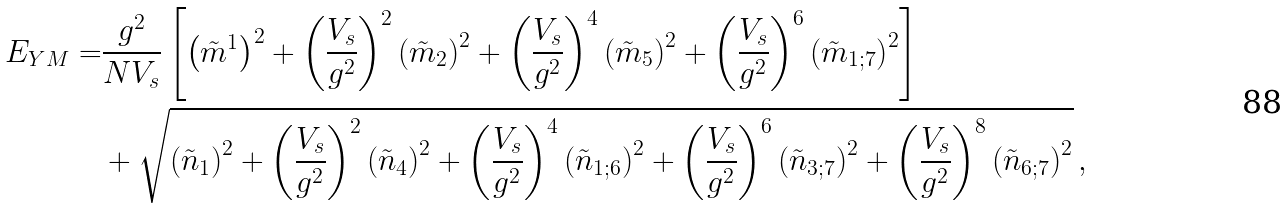<formula> <loc_0><loc_0><loc_500><loc_500>E _ { Y M } = & \frac { g ^ { 2 } } { N V _ { s } } \left [ \left ( \tilde { m } ^ { 1 } \right ) ^ { 2 } + \left ( \frac { V _ { s } } { g ^ { 2 } } \right ) ^ { 2 } \left ( \tilde { m } _ { 2 } \right ) ^ { 2 } + \left ( \frac { V _ { s } } { g ^ { 2 } } \right ) ^ { 4 } \left ( \tilde { m } _ { 5 } \right ) ^ { 2 } + \left ( \frac { V _ { s } } { g ^ { 2 } } \right ) ^ { 6 } \left ( \tilde { m } _ { 1 ; 7 } \right ) ^ { 2 } \right ] \\ & + \sqrt { \left ( \tilde { n } _ { 1 } \right ) ^ { 2 } + \left ( \frac { V _ { s } } { g ^ { 2 } } \right ) ^ { 2 } \left ( \tilde { n } _ { 4 } \right ) ^ { 2 } + \left ( \frac { V _ { s } } { g ^ { 2 } } \right ) ^ { 4 } \left ( \tilde { n } _ { 1 ; 6 } \right ) ^ { 2 } + \left ( \frac { V _ { s } } { g ^ { 2 } } \right ) ^ { 6 } \left ( \tilde { n } _ { 3 ; 7 } \right ) ^ { 2 } + \left ( \frac { V _ { s } } { g ^ { 2 } } \right ) ^ { 8 } \left ( \tilde { n } _ { 6 ; 7 } \right ) ^ { 2 } } \, ,</formula> 